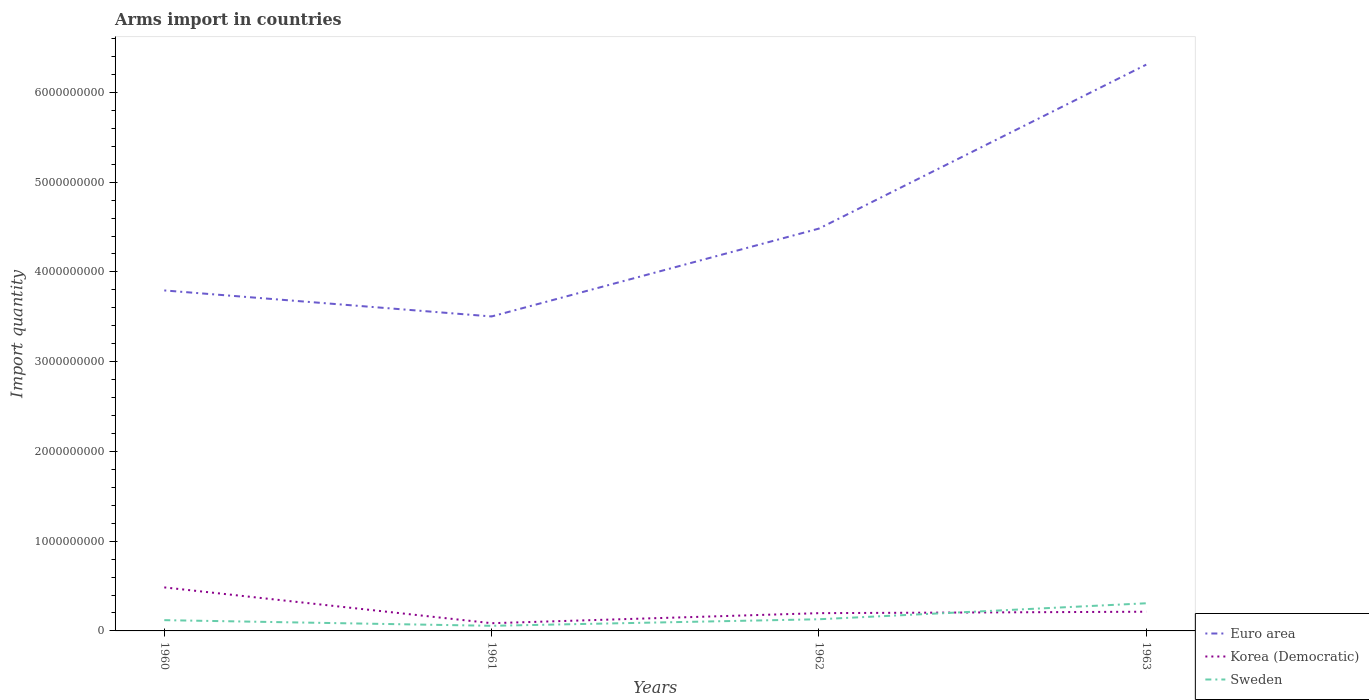Does the line corresponding to Euro area intersect with the line corresponding to Korea (Democratic)?
Make the answer very short. No. Across all years, what is the maximum total arms import in Sweden?
Keep it short and to the point. 5.70e+07. What is the total total arms import in Euro area in the graph?
Make the answer very short. -2.81e+09. What is the difference between the highest and the second highest total arms import in Euro area?
Provide a short and direct response. 2.81e+09. What is the difference between the highest and the lowest total arms import in Korea (Democratic)?
Provide a short and direct response. 1. How many lines are there?
Offer a very short reply. 3. Are the values on the major ticks of Y-axis written in scientific E-notation?
Offer a terse response. No. Does the graph contain grids?
Ensure brevity in your answer.  No. Where does the legend appear in the graph?
Keep it short and to the point. Bottom right. What is the title of the graph?
Provide a succinct answer. Arms import in countries. Does "Ukraine" appear as one of the legend labels in the graph?
Provide a succinct answer. No. What is the label or title of the X-axis?
Provide a short and direct response. Years. What is the label or title of the Y-axis?
Provide a short and direct response. Import quantity. What is the Import quantity in Euro area in 1960?
Make the answer very short. 3.79e+09. What is the Import quantity in Korea (Democratic) in 1960?
Provide a succinct answer. 4.85e+08. What is the Import quantity in Sweden in 1960?
Keep it short and to the point. 1.20e+08. What is the Import quantity in Euro area in 1961?
Make the answer very short. 3.50e+09. What is the Import quantity of Korea (Democratic) in 1961?
Provide a short and direct response. 8.60e+07. What is the Import quantity of Sweden in 1961?
Your answer should be very brief. 5.70e+07. What is the Import quantity of Euro area in 1962?
Your answer should be very brief. 4.48e+09. What is the Import quantity in Korea (Democratic) in 1962?
Your answer should be compact. 1.98e+08. What is the Import quantity of Sweden in 1962?
Your answer should be very brief. 1.30e+08. What is the Import quantity in Euro area in 1963?
Make the answer very short. 6.31e+09. What is the Import quantity in Korea (Democratic) in 1963?
Keep it short and to the point. 2.14e+08. What is the Import quantity of Sweden in 1963?
Your response must be concise. 3.08e+08. Across all years, what is the maximum Import quantity of Euro area?
Provide a short and direct response. 6.31e+09. Across all years, what is the maximum Import quantity of Korea (Democratic)?
Provide a succinct answer. 4.85e+08. Across all years, what is the maximum Import quantity of Sweden?
Offer a very short reply. 3.08e+08. Across all years, what is the minimum Import quantity of Euro area?
Offer a terse response. 3.50e+09. Across all years, what is the minimum Import quantity in Korea (Democratic)?
Offer a terse response. 8.60e+07. Across all years, what is the minimum Import quantity of Sweden?
Your answer should be very brief. 5.70e+07. What is the total Import quantity of Euro area in the graph?
Give a very brief answer. 1.81e+1. What is the total Import quantity in Korea (Democratic) in the graph?
Offer a terse response. 9.83e+08. What is the total Import quantity of Sweden in the graph?
Your response must be concise. 6.15e+08. What is the difference between the Import quantity of Euro area in 1960 and that in 1961?
Your response must be concise. 2.90e+08. What is the difference between the Import quantity in Korea (Democratic) in 1960 and that in 1961?
Your answer should be compact. 3.99e+08. What is the difference between the Import quantity in Sweden in 1960 and that in 1961?
Offer a very short reply. 6.30e+07. What is the difference between the Import quantity in Euro area in 1960 and that in 1962?
Ensure brevity in your answer.  -6.89e+08. What is the difference between the Import quantity of Korea (Democratic) in 1960 and that in 1962?
Give a very brief answer. 2.87e+08. What is the difference between the Import quantity of Sweden in 1960 and that in 1962?
Offer a terse response. -1.00e+07. What is the difference between the Import quantity in Euro area in 1960 and that in 1963?
Give a very brief answer. -2.52e+09. What is the difference between the Import quantity in Korea (Democratic) in 1960 and that in 1963?
Your answer should be compact. 2.71e+08. What is the difference between the Import quantity in Sweden in 1960 and that in 1963?
Ensure brevity in your answer.  -1.88e+08. What is the difference between the Import quantity in Euro area in 1961 and that in 1962?
Your answer should be very brief. -9.79e+08. What is the difference between the Import quantity in Korea (Democratic) in 1961 and that in 1962?
Your answer should be very brief. -1.12e+08. What is the difference between the Import quantity in Sweden in 1961 and that in 1962?
Make the answer very short. -7.30e+07. What is the difference between the Import quantity in Euro area in 1961 and that in 1963?
Your response must be concise. -2.81e+09. What is the difference between the Import quantity of Korea (Democratic) in 1961 and that in 1963?
Your answer should be compact. -1.28e+08. What is the difference between the Import quantity in Sweden in 1961 and that in 1963?
Your answer should be very brief. -2.51e+08. What is the difference between the Import quantity of Euro area in 1962 and that in 1963?
Keep it short and to the point. -1.83e+09. What is the difference between the Import quantity of Korea (Democratic) in 1962 and that in 1963?
Provide a short and direct response. -1.60e+07. What is the difference between the Import quantity of Sweden in 1962 and that in 1963?
Ensure brevity in your answer.  -1.78e+08. What is the difference between the Import quantity in Euro area in 1960 and the Import quantity in Korea (Democratic) in 1961?
Offer a terse response. 3.71e+09. What is the difference between the Import quantity in Euro area in 1960 and the Import quantity in Sweden in 1961?
Ensure brevity in your answer.  3.74e+09. What is the difference between the Import quantity in Korea (Democratic) in 1960 and the Import quantity in Sweden in 1961?
Offer a terse response. 4.28e+08. What is the difference between the Import quantity in Euro area in 1960 and the Import quantity in Korea (Democratic) in 1962?
Offer a terse response. 3.60e+09. What is the difference between the Import quantity in Euro area in 1960 and the Import quantity in Sweden in 1962?
Your response must be concise. 3.66e+09. What is the difference between the Import quantity of Korea (Democratic) in 1960 and the Import quantity of Sweden in 1962?
Keep it short and to the point. 3.55e+08. What is the difference between the Import quantity of Euro area in 1960 and the Import quantity of Korea (Democratic) in 1963?
Ensure brevity in your answer.  3.58e+09. What is the difference between the Import quantity of Euro area in 1960 and the Import quantity of Sweden in 1963?
Provide a short and direct response. 3.49e+09. What is the difference between the Import quantity in Korea (Democratic) in 1960 and the Import quantity in Sweden in 1963?
Provide a succinct answer. 1.77e+08. What is the difference between the Import quantity of Euro area in 1961 and the Import quantity of Korea (Democratic) in 1962?
Your response must be concise. 3.31e+09. What is the difference between the Import quantity in Euro area in 1961 and the Import quantity in Sweden in 1962?
Your answer should be very brief. 3.37e+09. What is the difference between the Import quantity of Korea (Democratic) in 1961 and the Import quantity of Sweden in 1962?
Keep it short and to the point. -4.40e+07. What is the difference between the Import quantity of Euro area in 1961 and the Import quantity of Korea (Democratic) in 1963?
Your response must be concise. 3.29e+09. What is the difference between the Import quantity of Euro area in 1961 and the Import quantity of Sweden in 1963?
Make the answer very short. 3.20e+09. What is the difference between the Import quantity of Korea (Democratic) in 1961 and the Import quantity of Sweden in 1963?
Offer a very short reply. -2.22e+08. What is the difference between the Import quantity of Euro area in 1962 and the Import quantity of Korea (Democratic) in 1963?
Keep it short and to the point. 4.27e+09. What is the difference between the Import quantity in Euro area in 1962 and the Import quantity in Sweden in 1963?
Your answer should be very brief. 4.18e+09. What is the difference between the Import quantity in Korea (Democratic) in 1962 and the Import quantity in Sweden in 1963?
Offer a terse response. -1.10e+08. What is the average Import quantity in Euro area per year?
Give a very brief answer. 4.52e+09. What is the average Import quantity of Korea (Democratic) per year?
Make the answer very short. 2.46e+08. What is the average Import quantity in Sweden per year?
Offer a very short reply. 1.54e+08. In the year 1960, what is the difference between the Import quantity in Euro area and Import quantity in Korea (Democratic)?
Keep it short and to the point. 3.31e+09. In the year 1960, what is the difference between the Import quantity of Euro area and Import quantity of Sweden?
Make the answer very short. 3.67e+09. In the year 1960, what is the difference between the Import quantity in Korea (Democratic) and Import quantity in Sweden?
Your response must be concise. 3.65e+08. In the year 1961, what is the difference between the Import quantity of Euro area and Import quantity of Korea (Democratic)?
Provide a short and direct response. 3.42e+09. In the year 1961, what is the difference between the Import quantity in Euro area and Import quantity in Sweden?
Make the answer very short. 3.45e+09. In the year 1961, what is the difference between the Import quantity of Korea (Democratic) and Import quantity of Sweden?
Provide a succinct answer. 2.90e+07. In the year 1962, what is the difference between the Import quantity in Euro area and Import quantity in Korea (Democratic)?
Give a very brief answer. 4.28e+09. In the year 1962, what is the difference between the Import quantity of Euro area and Import quantity of Sweden?
Give a very brief answer. 4.35e+09. In the year 1962, what is the difference between the Import quantity in Korea (Democratic) and Import quantity in Sweden?
Offer a terse response. 6.80e+07. In the year 1963, what is the difference between the Import quantity of Euro area and Import quantity of Korea (Democratic)?
Keep it short and to the point. 6.10e+09. In the year 1963, what is the difference between the Import quantity of Euro area and Import quantity of Sweden?
Your answer should be compact. 6.00e+09. In the year 1963, what is the difference between the Import quantity of Korea (Democratic) and Import quantity of Sweden?
Offer a very short reply. -9.40e+07. What is the ratio of the Import quantity in Euro area in 1960 to that in 1961?
Ensure brevity in your answer.  1.08. What is the ratio of the Import quantity in Korea (Democratic) in 1960 to that in 1961?
Your answer should be very brief. 5.64. What is the ratio of the Import quantity in Sweden in 1960 to that in 1961?
Provide a short and direct response. 2.11. What is the ratio of the Import quantity of Euro area in 1960 to that in 1962?
Provide a succinct answer. 0.85. What is the ratio of the Import quantity of Korea (Democratic) in 1960 to that in 1962?
Offer a very short reply. 2.45. What is the ratio of the Import quantity in Euro area in 1960 to that in 1963?
Your answer should be compact. 0.6. What is the ratio of the Import quantity in Korea (Democratic) in 1960 to that in 1963?
Offer a very short reply. 2.27. What is the ratio of the Import quantity of Sweden in 1960 to that in 1963?
Provide a short and direct response. 0.39. What is the ratio of the Import quantity of Euro area in 1961 to that in 1962?
Ensure brevity in your answer.  0.78. What is the ratio of the Import quantity in Korea (Democratic) in 1961 to that in 1962?
Your response must be concise. 0.43. What is the ratio of the Import quantity in Sweden in 1961 to that in 1962?
Your answer should be compact. 0.44. What is the ratio of the Import quantity in Euro area in 1961 to that in 1963?
Offer a very short reply. 0.56. What is the ratio of the Import quantity of Korea (Democratic) in 1961 to that in 1963?
Give a very brief answer. 0.4. What is the ratio of the Import quantity of Sweden in 1961 to that in 1963?
Offer a terse response. 0.19. What is the ratio of the Import quantity of Euro area in 1962 to that in 1963?
Offer a very short reply. 0.71. What is the ratio of the Import quantity of Korea (Democratic) in 1962 to that in 1963?
Your answer should be compact. 0.93. What is the ratio of the Import quantity of Sweden in 1962 to that in 1963?
Your answer should be compact. 0.42. What is the difference between the highest and the second highest Import quantity of Euro area?
Offer a terse response. 1.83e+09. What is the difference between the highest and the second highest Import quantity in Korea (Democratic)?
Offer a very short reply. 2.71e+08. What is the difference between the highest and the second highest Import quantity of Sweden?
Give a very brief answer. 1.78e+08. What is the difference between the highest and the lowest Import quantity of Euro area?
Ensure brevity in your answer.  2.81e+09. What is the difference between the highest and the lowest Import quantity of Korea (Democratic)?
Your answer should be very brief. 3.99e+08. What is the difference between the highest and the lowest Import quantity of Sweden?
Offer a very short reply. 2.51e+08. 